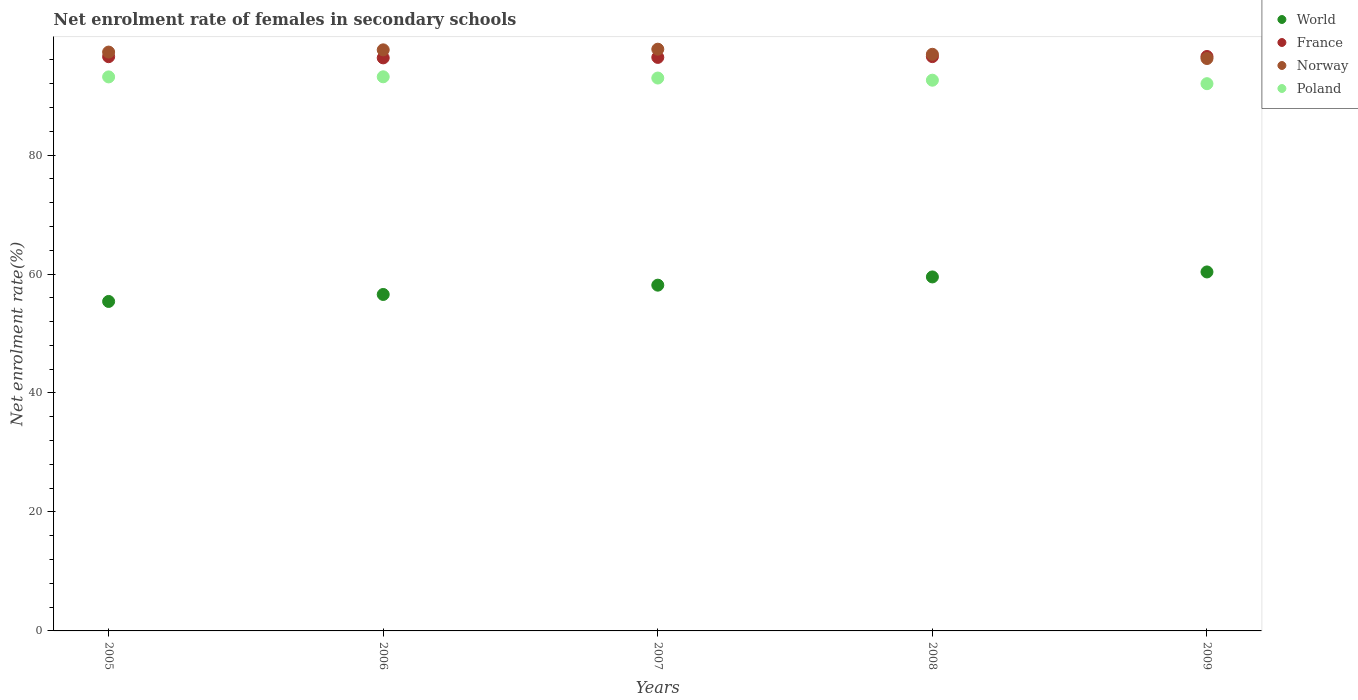Is the number of dotlines equal to the number of legend labels?
Provide a short and direct response. Yes. What is the net enrolment rate of females in secondary schools in France in 2005?
Your answer should be very brief. 96.53. Across all years, what is the maximum net enrolment rate of females in secondary schools in France?
Offer a terse response. 96.57. Across all years, what is the minimum net enrolment rate of females in secondary schools in Norway?
Provide a succinct answer. 96.23. In which year was the net enrolment rate of females in secondary schools in France minimum?
Your response must be concise. 2006. What is the total net enrolment rate of females in secondary schools in Norway in the graph?
Your answer should be compact. 485.95. What is the difference between the net enrolment rate of females in secondary schools in World in 2007 and that in 2008?
Your response must be concise. -1.38. What is the difference between the net enrolment rate of females in secondary schools in France in 2007 and the net enrolment rate of females in secondary schools in Poland in 2008?
Your response must be concise. 3.83. What is the average net enrolment rate of females in secondary schools in France per year?
Keep it short and to the point. 96.48. In the year 2008, what is the difference between the net enrolment rate of females in secondary schools in World and net enrolment rate of females in secondary schools in Norway?
Your answer should be very brief. -37.43. What is the ratio of the net enrolment rate of females in secondary schools in Norway in 2008 to that in 2009?
Your answer should be compact. 1.01. Is the difference between the net enrolment rate of females in secondary schools in World in 2005 and 2009 greater than the difference between the net enrolment rate of females in secondary schools in Norway in 2005 and 2009?
Your answer should be compact. No. What is the difference between the highest and the second highest net enrolment rate of females in secondary schools in Norway?
Provide a short and direct response. 0.11. What is the difference between the highest and the lowest net enrolment rate of females in secondary schools in Norway?
Your response must be concise. 1.57. Is the sum of the net enrolment rate of females in secondary schools in Norway in 2005 and 2007 greater than the maximum net enrolment rate of females in secondary schools in France across all years?
Your answer should be compact. Yes. Does the net enrolment rate of females in secondary schools in World monotonically increase over the years?
Keep it short and to the point. Yes. Is the net enrolment rate of females in secondary schools in Poland strictly greater than the net enrolment rate of females in secondary schools in France over the years?
Offer a terse response. No. How many dotlines are there?
Offer a very short reply. 4. How many years are there in the graph?
Give a very brief answer. 5. What is the difference between two consecutive major ticks on the Y-axis?
Make the answer very short. 20. Are the values on the major ticks of Y-axis written in scientific E-notation?
Provide a succinct answer. No. Does the graph contain any zero values?
Your response must be concise. No. Where does the legend appear in the graph?
Your answer should be compact. Top right. How many legend labels are there?
Make the answer very short. 4. How are the legend labels stacked?
Your answer should be compact. Vertical. What is the title of the graph?
Offer a very short reply. Net enrolment rate of females in secondary schools. What is the label or title of the X-axis?
Provide a succinct answer. Years. What is the label or title of the Y-axis?
Ensure brevity in your answer.  Net enrolment rate(%). What is the Net enrolment rate(%) in World in 2005?
Give a very brief answer. 55.39. What is the Net enrolment rate(%) of France in 2005?
Ensure brevity in your answer.  96.53. What is the Net enrolment rate(%) in Norway in 2005?
Give a very brief answer. 97.31. What is the Net enrolment rate(%) in Poland in 2005?
Provide a succinct answer. 93.14. What is the Net enrolment rate(%) of World in 2006?
Offer a terse response. 56.56. What is the Net enrolment rate(%) in France in 2006?
Offer a very short reply. 96.34. What is the Net enrolment rate(%) in Norway in 2006?
Provide a short and direct response. 97.68. What is the Net enrolment rate(%) in Poland in 2006?
Ensure brevity in your answer.  93.15. What is the Net enrolment rate(%) in World in 2007?
Give a very brief answer. 58.13. What is the Net enrolment rate(%) of France in 2007?
Keep it short and to the point. 96.41. What is the Net enrolment rate(%) of Norway in 2007?
Give a very brief answer. 97.79. What is the Net enrolment rate(%) in Poland in 2007?
Offer a terse response. 92.95. What is the Net enrolment rate(%) in World in 2008?
Provide a succinct answer. 59.51. What is the Net enrolment rate(%) in France in 2008?
Your response must be concise. 96.55. What is the Net enrolment rate(%) of Norway in 2008?
Make the answer very short. 96.94. What is the Net enrolment rate(%) in Poland in 2008?
Your response must be concise. 92.58. What is the Net enrolment rate(%) in World in 2009?
Your answer should be compact. 60.35. What is the Net enrolment rate(%) in France in 2009?
Make the answer very short. 96.57. What is the Net enrolment rate(%) of Norway in 2009?
Your response must be concise. 96.23. What is the Net enrolment rate(%) in Poland in 2009?
Give a very brief answer. 92. Across all years, what is the maximum Net enrolment rate(%) in World?
Your answer should be compact. 60.35. Across all years, what is the maximum Net enrolment rate(%) of France?
Your answer should be very brief. 96.57. Across all years, what is the maximum Net enrolment rate(%) in Norway?
Make the answer very short. 97.79. Across all years, what is the maximum Net enrolment rate(%) in Poland?
Offer a very short reply. 93.15. Across all years, what is the minimum Net enrolment rate(%) of World?
Your answer should be compact. 55.39. Across all years, what is the minimum Net enrolment rate(%) in France?
Keep it short and to the point. 96.34. Across all years, what is the minimum Net enrolment rate(%) of Norway?
Offer a very short reply. 96.23. Across all years, what is the minimum Net enrolment rate(%) in Poland?
Give a very brief answer. 92. What is the total Net enrolment rate(%) in World in the graph?
Keep it short and to the point. 289.93. What is the total Net enrolment rate(%) in France in the graph?
Your response must be concise. 482.4. What is the total Net enrolment rate(%) of Norway in the graph?
Offer a terse response. 485.95. What is the total Net enrolment rate(%) of Poland in the graph?
Offer a very short reply. 463.82. What is the difference between the Net enrolment rate(%) in World in 2005 and that in 2006?
Your answer should be very brief. -1.17. What is the difference between the Net enrolment rate(%) of France in 2005 and that in 2006?
Provide a succinct answer. 0.2. What is the difference between the Net enrolment rate(%) of Norway in 2005 and that in 2006?
Provide a succinct answer. -0.37. What is the difference between the Net enrolment rate(%) of Poland in 2005 and that in 2006?
Give a very brief answer. -0.02. What is the difference between the Net enrolment rate(%) in World in 2005 and that in 2007?
Keep it short and to the point. -2.74. What is the difference between the Net enrolment rate(%) of France in 2005 and that in 2007?
Give a very brief answer. 0.12. What is the difference between the Net enrolment rate(%) in Norway in 2005 and that in 2007?
Offer a very short reply. -0.49. What is the difference between the Net enrolment rate(%) of Poland in 2005 and that in 2007?
Keep it short and to the point. 0.19. What is the difference between the Net enrolment rate(%) in World in 2005 and that in 2008?
Keep it short and to the point. -4.12. What is the difference between the Net enrolment rate(%) of France in 2005 and that in 2008?
Keep it short and to the point. -0.01. What is the difference between the Net enrolment rate(%) in Norway in 2005 and that in 2008?
Your response must be concise. 0.37. What is the difference between the Net enrolment rate(%) in Poland in 2005 and that in 2008?
Offer a terse response. 0.56. What is the difference between the Net enrolment rate(%) of World in 2005 and that in 2009?
Give a very brief answer. -4.96. What is the difference between the Net enrolment rate(%) of France in 2005 and that in 2009?
Keep it short and to the point. -0.03. What is the difference between the Net enrolment rate(%) in Norway in 2005 and that in 2009?
Provide a succinct answer. 1.08. What is the difference between the Net enrolment rate(%) in Poland in 2005 and that in 2009?
Give a very brief answer. 1.14. What is the difference between the Net enrolment rate(%) in World in 2006 and that in 2007?
Your answer should be very brief. -1.57. What is the difference between the Net enrolment rate(%) of France in 2006 and that in 2007?
Make the answer very short. -0.08. What is the difference between the Net enrolment rate(%) in Norway in 2006 and that in 2007?
Your answer should be very brief. -0.11. What is the difference between the Net enrolment rate(%) of Poland in 2006 and that in 2007?
Provide a short and direct response. 0.21. What is the difference between the Net enrolment rate(%) of World in 2006 and that in 2008?
Your response must be concise. -2.95. What is the difference between the Net enrolment rate(%) of France in 2006 and that in 2008?
Offer a terse response. -0.21. What is the difference between the Net enrolment rate(%) of Norway in 2006 and that in 2008?
Your response must be concise. 0.74. What is the difference between the Net enrolment rate(%) of Poland in 2006 and that in 2008?
Your answer should be very brief. 0.57. What is the difference between the Net enrolment rate(%) in World in 2006 and that in 2009?
Give a very brief answer. -3.79. What is the difference between the Net enrolment rate(%) in France in 2006 and that in 2009?
Ensure brevity in your answer.  -0.23. What is the difference between the Net enrolment rate(%) in Norway in 2006 and that in 2009?
Ensure brevity in your answer.  1.46. What is the difference between the Net enrolment rate(%) in Poland in 2006 and that in 2009?
Ensure brevity in your answer.  1.16. What is the difference between the Net enrolment rate(%) in World in 2007 and that in 2008?
Your response must be concise. -1.38. What is the difference between the Net enrolment rate(%) in France in 2007 and that in 2008?
Ensure brevity in your answer.  -0.13. What is the difference between the Net enrolment rate(%) of Norway in 2007 and that in 2008?
Your response must be concise. 0.86. What is the difference between the Net enrolment rate(%) in Poland in 2007 and that in 2008?
Keep it short and to the point. 0.36. What is the difference between the Net enrolment rate(%) of World in 2007 and that in 2009?
Provide a succinct answer. -2.22. What is the difference between the Net enrolment rate(%) in France in 2007 and that in 2009?
Your answer should be very brief. -0.15. What is the difference between the Net enrolment rate(%) in Norway in 2007 and that in 2009?
Keep it short and to the point. 1.57. What is the difference between the Net enrolment rate(%) in Poland in 2007 and that in 2009?
Provide a short and direct response. 0.95. What is the difference between the Net enrolment rate(%) of World in 2008 and that in 2009?
Provide a short and direct response. -0.84. What is the difference between the Net enrolment rate(%) of France in 2008 and that in 2009?
Provide a succinct answer. -0.02. What is the difference between the Net enrolment rate(%) in Norway in 2008 and that in 2009?
Offer a terse response. 0.71. What is the difference between the Net enrolment rate(%) of Poland in 2008 and that in 2009?
Your answer should be very brief. 0.58. What is the difference between the Net enrolment rate(%) in World in 2005 and the Net enrolment rate(%) in France in 2006?
Your answer should be compact. -40.95. What is the difference between the Net enrolment rate(%) of World in 2005 and the Net enrolment rate(%) of Norway in 2006?
Provide a short and direct response. -42.3. What is the difference between the Net enrolment rate(%) in World in 2005 and the Net enrolment rate(%) in Poland in 2006?
Offer a very short reply. -37.77. What is the difference between the Net enrolment rate(%) of France in 2005 and the Net enrolment rate(%) of Norway in 2006?
Your answer should be compact. -1.15. What is the difference between the Net enrolment rate(%) in France in 2005 and the Net enrolment rate(%) in Poland in 2006?
Offer a very short reply. 3.38. What is the difference between the Net enrolment rate(%) in Norway in 2005 and the Net enrolment rate(%) in Poland in 2006?
Make the answer very short. 4.16. What is the difference between the Net enrolment rate(%) in World in 2005 and the Net enrolment rate(%) in France in 2007?
Offer a terse response. -41.03. What is the difference between the Net enrolment rate(%) of World in 2005 and the Net enrolment rate(%) of Norway in 2007?
Provide a succinct answer. -42.41. What is the difference between the Net enrolment rate(%) of World in 2005 and the Net enrolment rate(%) of Poland in 2007?
Keep it short and to the point. -37.56. What is the difference between the Net enrolment rate(%) of France in 2005 and the Net enrolment rate(%) of Norway in 2007?
Offer a terse response. -1.26. What is the difference between the Net enrolment rate(%) in France in 2005 and the Net enrolment rate(%) in Poland in 2007?
Give a very brief answer. 3.59. What is the difference between the Net enrolment rate(%) in Norway in 2005 and the Net enrolment rate(%) in Poland in 2007?
Offer a very short reply. 4.36. What is the difference between the Net enrolment rate(%) in World in 2005 and the Net enrolment rate(%) in France in 2008?
Your answer should be very brief. -41.16. What is the difference between the Net enrolment rate(%) in World in 2005 and the Net enrolment rate(%) in Norway in 2008?
Your response must be concise. -41.55. What is the difference between the Net enrolment rate(%) in World in 2005 and the Net enrolment rate(%) in Poland in 2008?
Your answer should be compact. -37.2. What is the difference between the Net enrolment rate(%) of France in 2005 and the Net enrolment rate(%) of Norway in 2008?
Make the answer very short. -0.4. What is the difference between the Net enrolment rate(%) of France in 2005 and the Net enrolment rate(%) of Poland in 2008?
Your answer should be very brief. 3.95. What is the difference between the Net enrolment rate(%) in Norway in 2005 and the Net enrolment rate(%) in Poland in 2008?
Your response must be concise. 4.73. What is the difference between the Net enrolment rate(%) in World in 2005 and the Net enrolment rate(%) in France in 2009?
Offer a terse response. -41.18. What is the difference between the Net enrolment rate(%) of World in 2005 and the Net enrolment rate(%) of Norway in 2009?
Your response must be concise. -40.84. What is the difference between the Net enrolment rate(%) of World in 2005 and the Net enrolment rate(%) of Poland in 2009?
Keep it short and to the point. -36.61. What is the difference between the Net enrolment rate(%) in France in 2005 and the Net enrolment rate(%) in Norway in 2009?
Your response must be concise. 0.31. What is the difference between the Net enrolment rate(%) in France in 2005 and the Net enrolment rate(%) in Poland in 2009?
Keep it short and to the point. 4.54. What is the difference between the Net enrolment rate(%) in Norway in 2005 and the Net enrolment rate(%) in Poland in 2009?
Your answer should be compact. 5.31. What is the difference between the Net enrolment rate(%) in World in 2006 and the Net enrolment rate(%) in France in 2007?
Offer a terse response. -39.85. What is the difference between the Net enrolment rate(%) in World in 2006 and the Net enrolment rate(%) in Norway in 2007?
Your answer should be very brief. -41.23. What is the difference between the Net enrolment rate(%) of World in 2006 and the Net enrolment rate(%) of Poland in 2007?
Provide a succinct answer. -36.38. What is the difference between the Net enrolment rate(%) of France in 2006 and the Net enrolment rate(%) of Norway in 2007?
Give a very brief answer. -1.46. What is the difference between the Net enrolment rate(%) in France in 2006 and the Net enrolment rate(%) in Poland in 2007?
Provide a succinct answer. 3.39. What is the difference between the Net enrolment rate(%) of Norway in 2006 and the Net enrolment rate(%) of Poland in 2007?
Provide a short and direct response. 4.74. What is the difference between the Net enrolment rate(%) in World in 2006 and the Net enrolment rate(%) in France in 2008?
Make the answer very short. -39.98. What is the difference between the Net enrolment rate(%) of World in 2006 and the Net enrolment rate(%) of Norway in 2008?
Keep it short and to the point. -40.38. What is the difference between the Net enrolment rate(%) in World in 2006 and the Net enrolment rate(%) in Poland in 2008?
Provide a short and direct response. -36.02. What is the difference between the Net enrolment rate(%) of France in 2006 and the Net enrolment rate(%) of Norway in 2008?
Keep it short and to the point. -0.6. What is the difference between the Net enrolment rate(%) of France in 2006 and the Net enrolment rate(%) of Poland in 2008?
Provide a short and direct response. 3.75. What is the difference between the Net enrolment rate(%) of Norway in 2006 and the Net enrolment rate(%) of Poland in 2008?
Provide a succinct answer. 5.1. What is the difference between the Net enrolment rate(%) of World in 2006 and the Net enrolment rate(%) of France in 2009?
Provide a short and direct response. -40.01. What is the difference between the Net enrolment rate(%) of World in 2006 and the Net enrolment rate(%) of Norway in 2009?
Ensure brevity in your answer.  -39.67. What is the difference between the Net enrolment rate(%) in World in 2006 and the Net enrolment rate(%) in Poland in 2009?
Your answer should be compact. -35.44. What is the difference between the Net enrolment rate(%) in France in 2006 and the Net enrolment rate(%) in Norway in 2009?
Your response must be concise. 0.11. What is the difference between the Net enrolment rate(%) in France in 2006 and the Net enrolment rate(%) in Poland in 2009?
Your answer should be compact. 4.34. What is the difference between the Net enrolment rate(%) of Norway in 2006 and the Net enrolment rate(%) of Poland in 2009?
Offer a very short reply. 5.68. What is the difference between the Net enrolment rate(%) in World in 2007 and the Net enrolment rate(%) in France in 2008?
Your answer should be very brief. -38.42. What is the difference between the Net enrolment rate(%) of World in 2007 and the Net enrolment rate(%) of Norway in 2008?
Offer a terse response. -38.81. What is the difference between the Net enrolment rate(%) in World in 2007 and the Net enrolment rate(%) in Poland in 2008?
Offer a very short reply. -34.46. What is the difference between the Net enrolment rate(%) in France in 2007 and the Net enrolment rate(%) in Norway in 2008?
Ensure brevity in your answer.  -0.52. What is the difference between the Net enrolment rate(%) in France in 2007 and the Net enrolment rate(%) in Poland in 2008?
Provide a short and direct response. 3.83. What is the difference between the Net enrolment rate(%) of Norway in 2007 and the Net enrolment rate(%) of Poland in 2008?
Offer a terse response. 5.21. What is the difference between the Net enrolment rate(%) of World in 2007 and the Net enrolment rate(%) of France in 2009?
Provide a short and direct response. -38.44. What is the difference between the Net enrolment rate(%) in World in 2007 and the Net enrolment rate(%) in Norway in 2009?
Make the answer very short. -38.1. What is the difference between the Net enrolment rate(%) of World in 2007 and the Net enrolment rate(%) of Poland in 2009?
Offer a very short reply. -33.87. What is the difference between the Net enrolment rate(%) in France in 2007 and the Net enrolment rate(%) in Norway in 2009?
Offer a very short reply. 0.19. What is the difference between the Net enrolment rate(%) in France in 2007 and the Net enrolment rate(%) in Poland in 2009?
Offer a very short reply. 4.42. What is the difference between the Net enrolment rate(%) of Norway in 2007 and the Net enrolment rate(%) of Poland in 2009?
Your response must be concise. 5.8. What is the difference between the Net enrolment rate(%) of World in 2008 and the Net enrolment rate(%) of France in 2009?
Make the answer very short. -37.06. What is the difference between the Net enrolment rate(%) in World in 2008 and the Net enrolment rate(%) in Norway in 2009?
Make the answer very short. -36.72. What is the difference between the Net enrolment rate(%) of World in 2008 and the Net enrolment rate(%) of Poland in 2009?
Your answer should be very brief. -32.49. What is the difference between the Net enrolment rate(%) of France in 2008 and the Net enrolment rate(%) of Norway in 2009?
Offer a very short reply. 0.32. What is the difference between the Net enrolment rate(%) of France in 2008 and the Net enrolment rate(%) of Poland in 2009?
Keep it short and to the point. 4.55. What is the difference between the Net enrolment rate(%) in Norway in 2008 and the Net enrolment rate(%) in Poland in 2009?
Provide a short and direct response. 4.94. What is the average Net enrolment rate(%) of World per year?
Your answer should be compact. 57.99. What is the average Net enrolment rate(%) in France per year?
Your answer should be compact. 96.48. What is the average Net enrolment rate(%) of Norway per year?
Ensure brevity in your answer.  97.19. What is the average Net enrolment rate(%) in Poland per year?
Your answer should be compact. 92.76. In the year 2005, what is the difference between the Net enrolment rate(%) in World and Net enrolment rate(%) in France?
Your answer should be very brief. -41.15. In the year 2005, what is the difference between the Net enrolment rate(%) in World and Net enrolment rate(%) in Norway?
Offer a very short reply. -41.92. In the year 2005, what is the difference between the Net enrolment rate(%) of World and Net enrolment rate(%) of Poland?
Make the answer very short. -37.75. In the year 2005, what is the difference between the Net enrolment rate(%) of France and Net enrolment rate(%) of Norway?
Keep it short and to the point. -0.78. In the year 2005, what is the difference between the Net enrolment rate(%) in France and Net enrolment rate(%) in Poland?
Keep it short and to the point. 3.4. In the year 2005, what is the difference between the Net enrolment rate(%) of Norway and Net enrolment rate(%) of Poland?
Ensure brevity in your answer.  4.17. In the year 2006, what is the difference between the Net enrolment rate(%) in World and Net enrolment rate(%) in France?
Provide a succinct answer. -39.77. In the year 2006, what is the difference between the Net enrolment rate(%) of World and Net enrolment rate(%) of Norway?
Your answer should be compact. -41.12. In the year 2006, what is the difference between the Net enrolment rate(%) in World and Net enrolment rate(%) in Poland?
Ensure brevity in your answer.  -36.59. In the year 2006, what is the difference between the Net enrolment rate(%) in France and Net enrolment rate(%) in Norway?
Make the answer very short. -1.35. In the year 2006, what is the difference between the Net enrolment rate(%) of France and Net enrolment rate(%) of Poland?
Your response must be concise. 3.18. In the year 2006, what is the difference between the Net enrolment rate(%) of Norway and Net enrolment rate(%) of Poland?
Your response must be concise. 4.53. In the year 2007, what is the difference between the Net enrolment rate(%) in World and Net enrolment rate(%) in France?
Give a very brief answer. -38.29. In the year 2007, what is the difference between the Net enrolment rate(%) of World and Net enrolment rate(%) of Norway?
Your answer should be compact. -39.67. In the year 2007, what is the difference between the Net enrolment rate(%) in World and Net enrolment rate(%) in Poland?
Ensure brevity in your answer.  -34.82. In the year 2007, what is the difference between the Net enrolment rate(%) of France and Net enrolment rate(%) of Norway?
Offer a very short reply. -1.38. In the year 2007, what is the difference between the Net enrolment rate(%) of France and Net enrolment rate(%) of Poland?
Offer a terse response. 3.47. In the year 2007, what is the difference between the Net enrolment rate(%) of Norway and Net enrolment rate(%) of Poland?
Keep it short and to the point. 4.85. In the year 2008, what is the difference between the Net enrolment rate(%) in World and Net enrolment rate(%) in France?
Your response must be concise. -37.04. In the year 2008, what is the difference between the Net enrolment rate(%) in World and Net enrolment rate(%) in Norway?
Your answer should be very brief. -37.43. In the year 2008, what is the difference between the Net enrolment rate(%) of World and Net enrolment rate(%) of Poland?
Give a very brief answer. -33.07. In the year 2008, what is the difference between the Net enrolment rate(%) in France and Net enrolment rate(%) in Norway?
Keep it short and to the point. -0.39. In the year 2008, what is the difference between the Net enrolment rate(%) in France and Net enrolment rate(%) in Poland?
Give a very brief answer. 3.96. In the year 2008, what is the difference between the Net enrolment rate(%) of Norway and Net enrolment rate(%) of Poland?
Provide a succinct answer. 4.36. In the year 2009, what is the difference between the Net enrolment rate(%) of World and Net enrolment rate(%) of France?
Give a very brief answer. -36.22. In the year 2009, what is the difference between the Net enrolment rate(%) in World and Net enrolment rate(%) in Norway?
Your answer should be very brief. -35.88. In the year 2009, what is the difference between the Net enrolment rate(%) of World and Net enrolment rate(%) of Poland?
Offer a very short reply. -31.65. In the year 2009, what is the difference between the Net enrolment rate(%) of France and Net enrolment rate(%) of Norway?
Provide a short and direct response. 0.34. In the year 2009, what is the difference between the Net enrolment rate(%) of France and Net enrolment rate(%) of Poland?
Make the answer very short. 4.57. In the year 2009, what is the difference between the Net enrolment rate(%) in Norway and Net enrolment rate(%) in Poland?
Make the answer very short. 4.23. What is the ratio of the Net enrolment rate(%) of World in 2005 to that in 2006?
Your answer should be compact. 0.98. What is the ratio of the Net enrolment rate(%) in Norway in 2005 to that in 2006?
Your answer should be very brief. 1. What is the ratio of the Net enrolment rate(%) in World in 2005 to that in 2007?
Ensure brevity in your answer.  0.95. What is the ratio of the Net enrolment rate(%) in France in 2005 to that in 2007?
Offer a terse response. 1. What is the ratio of the Net enrolment rate(%) of Norway in 2005 to that in 2007?
Offer a very short reply. 0.99. What is the ratio of the Net enrolment rate(%) of World in 2005 to that in 2008?
Your response must be concise. 0.93. What is the ratio of the Net enrolment rate(%) in France in 2005 to that in 2008?
Your answer should be very brief. 1. What is the ratio of the Net enrolment rate(%) in World in 2005 to that in 2009?
Offer a terse response. 0.92. What is the ratio of the Net enrolment rate(%) in France in 2005 to that in 2009?
Provide a succinct answer. 1. What is the ratio of the Net enrolment rate(%) in Norway in 2005 to that in 2009?
Provide a short and direct response. 1.01. What is the ratio of the Net enrolment rate(%) of Poland in 2005 to that in 2009?
Provide a short and direct response. 1.01. What is the ratio of the Net enrolment rate(%) of World in 2006 to that in 2007?
Your answer should be very brief. 0.97. What is the ratio of the Net enrolment rate(%) in Poland in 2006 to that in 2007?
Your response must be concise. 1. What is the ratio of the Net enrolment rate(%) in World in 2006 to that in 2008?
Your answer should be very brief. 0.95. What is the ratio of the Net enrolment rate(%) in France in 2006 to that in 2008?
Provide a short and direct response. 1. What is the ratio of the Net enrolment rate(%) of Norway in 2006 to that in 2008?
Your answer should be compact. 1.01. What is the ratio of the Net enrolment rate(%) in Poland in 2006 to that in 2008?
Offer a terse response. 1.01. What is the ratio of the Net enrolment rate(%) of World in 2006 to that in 2009?
Ensure brevity in your answer.  0.94. What is the ratio of the Net enrolment rate(%) of Norway in 2006 to that in 2009?
Keep it short and to the point. 1.02. What is the ratio of the Net enrolment rate(%) in Poland in 2006 to that in 2009?
Keep it short and to the point. 1.01. What is the ratio of the Net enrolment rate(%) of World in 2007 to that in 2008?
Your answer should be very brief. 0.98. What is the ratio of the Net enrolment rate(%) of Norway in 2007 to that in 2008?
Make the answer very short. 1.01. What is the ratio of the Net enrolment rate(%) of Poland in 2007 to that in 2008?
Your response must be concise. 1. What is the ratio of the Net enrolment rate(%) of World in 2007 to that in 2009?
Offer a very short reply. 0.96. What is the ratio of the Net enrolment rate(%) in Norway in 2007 to that in 2009?
Your response must be concise. 1.02. What is the ratio of the Net enrolment rate(%) of Poland in 2007 to that in 2009?
Provide a succinct answer. 1.01. What is the ratio of the Net enrolment rate(%) of World in 2008 to that in 2009?
Keep it short and to the point. 0.99. What is the ratio of the Net enrolment rate(%) in France in 2008 to that in 2009?
Offer a very short reply. 1. What is the ratio of the Net enrolment rate(%) of Norway in 2008 to that in 2009?
Offer a terse response. 1.01. What is the ratio of the Net enrolment rate(%) of Poland in 2008 to that in 2009?
Keep it short and to the point. 1.01. What is the difference between the highest and the second highest Net enrolment rate(%) in World?
Offer a terse response. 0.84. What is the difference between the highest and the second highest Net enrolment rate(%) of France?
Offer a terse response. 0.02. What is the difference between the highest and the second highest Net enrolment rate(%) of Norway?
Keep it short and to the point. 0.11. What is the difference between the highest and the second highest Net enrolment rate(%) of Poland?
Offer a very short reply. 0.02. What is the difference between the highest and the lowest Net enrolment rate(%) in World?
Keep it short and to the point. 4.96. What is the difference between the highest and the lowest Net enrolment rate(%) in France?
Offer a very short reply. 0.23. What is the difference between the highest and the lowest Net enrolment rate(%) in Norway?
Make the answer very short. 1.57. What is the difference between the highest and the lowest Net enrolment rate(%) of Poland?
Your response must be concise. 1.16. 